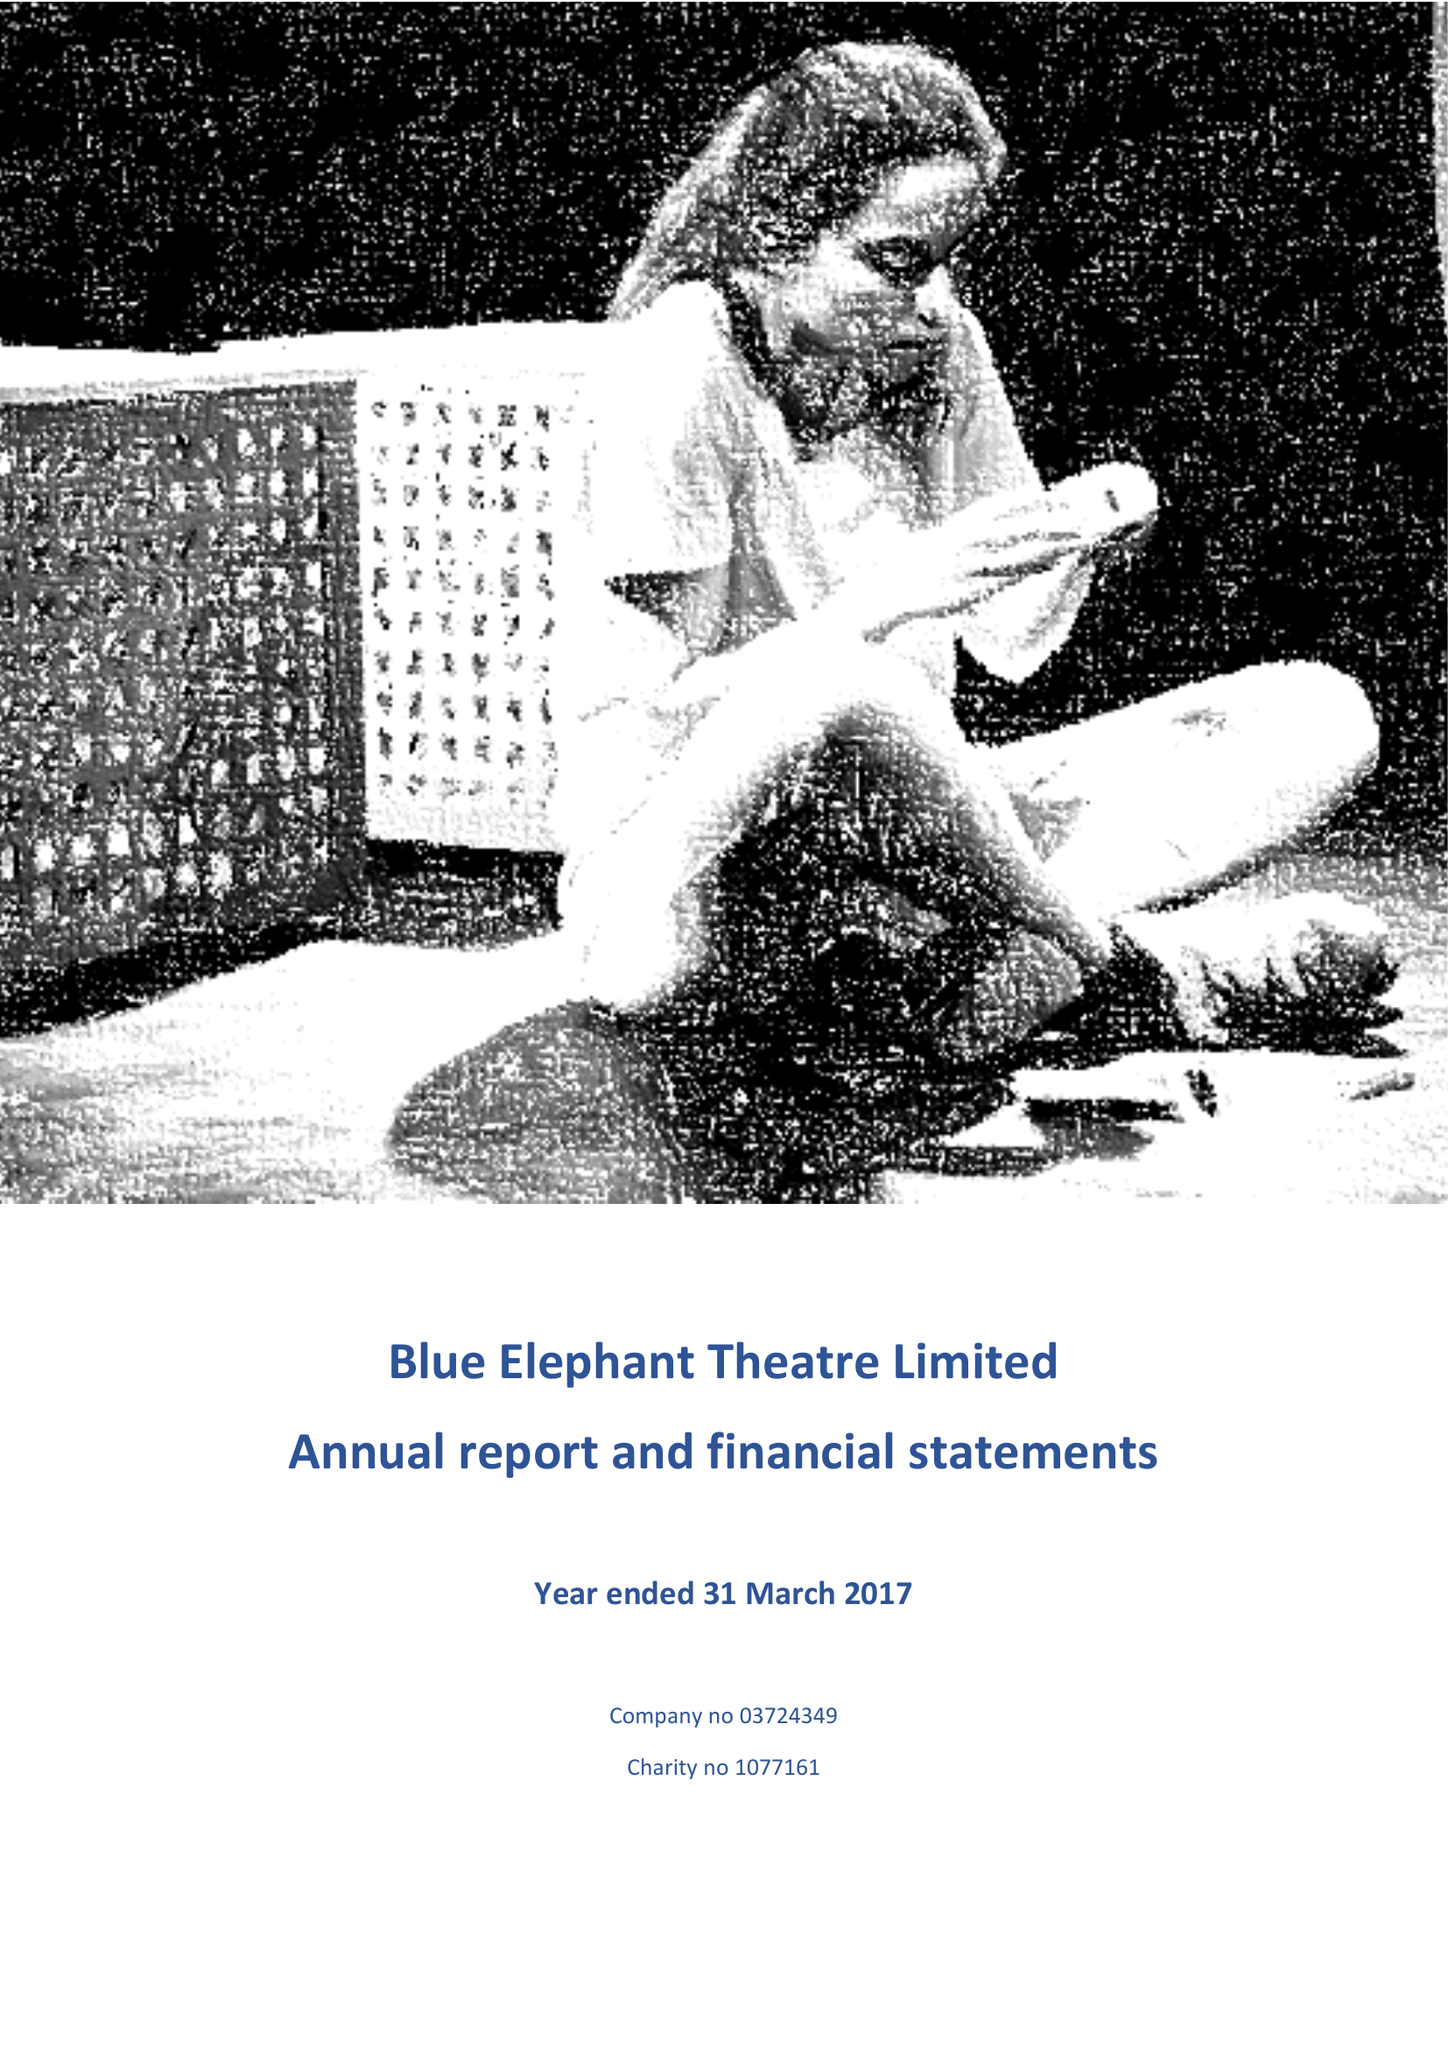What is the value for the report_date?
Answer the question using a single word or phrase. 2017-03-31 